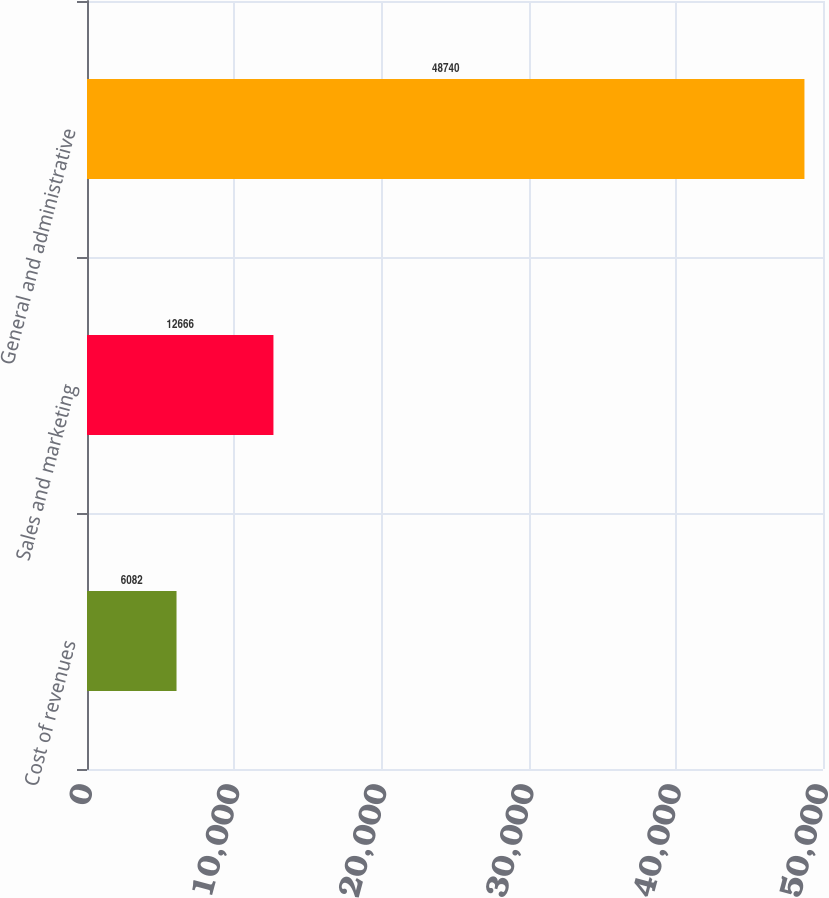<chart> <loc_0><loc_0><loc_500><loc_500><bar_chart><fcel>Cost of revenues<fcel>Sales and marketing<fcel>General and administrative<nl><fcel>6082<fcel>12666<fcel>48740<nl></chart> 